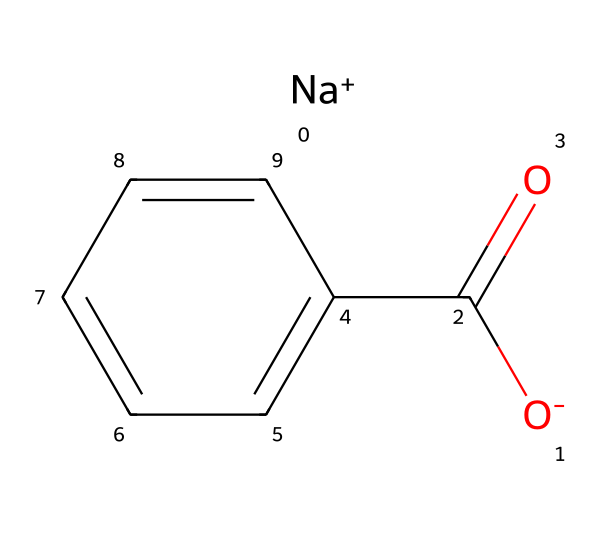What is the chemical name of this compound? The SMILES representation reveals the structure of sodium benzoate, comprised of a benzoate ion (C(=O)c1ccccc1) bonded to a sodium ion ([Na+]). Thus, the name of the compound is derived from its components: sodium and benzoate.
Answer: sodium benzoate How many carbon atoms are in the structure? Analyzing the structure provided in the SMILES, the benzoate part (c1ccccc1) has six carbon atoms in the aromatic ring, and one additional carbon is present in the carboxylate group (C(=O)). Hence, a total of seven carbon atoms are identified.
Answer: seven What type of bonding is present in the carboxylate group? The carboxylate group (C(=O)O-) exhibits covalent bonding, as indicated by the carbon-oxygen double bond (C=O) and the single bond to the negatively charged oxygen (O-). Covalent bonds occur due to electron sharing, which is consistent with this functional group.
Answer: covalent How many total atoms are in the molecule? The molecule consists of seven carbon atoms, three oxygen atoms (one in the carboxylate group and two in total including the double bond), and one sodium atom. Summing together gives a total of eleven atoms in the sodium benzoate structure.
Answer: eleven Which part of the structure is responsible for its preservative function? The carboxylate functional group (C(=O)O-) is crucial for the preservative function of sodium benzoate. The presence of this group enables interactions with microbial cells, inhibiting their growth. This property is fundamentally linked to the chemical's function as a preservative.
Answer: carboxylate group What is the oxidation state of sodium in this compound? The oxidation state of sodium in this compound, represented by the [Na+], indicates a +1 oxidation state. This is typical for alkali metals such as sodium when they form ionic compounds.
Answer: +1 